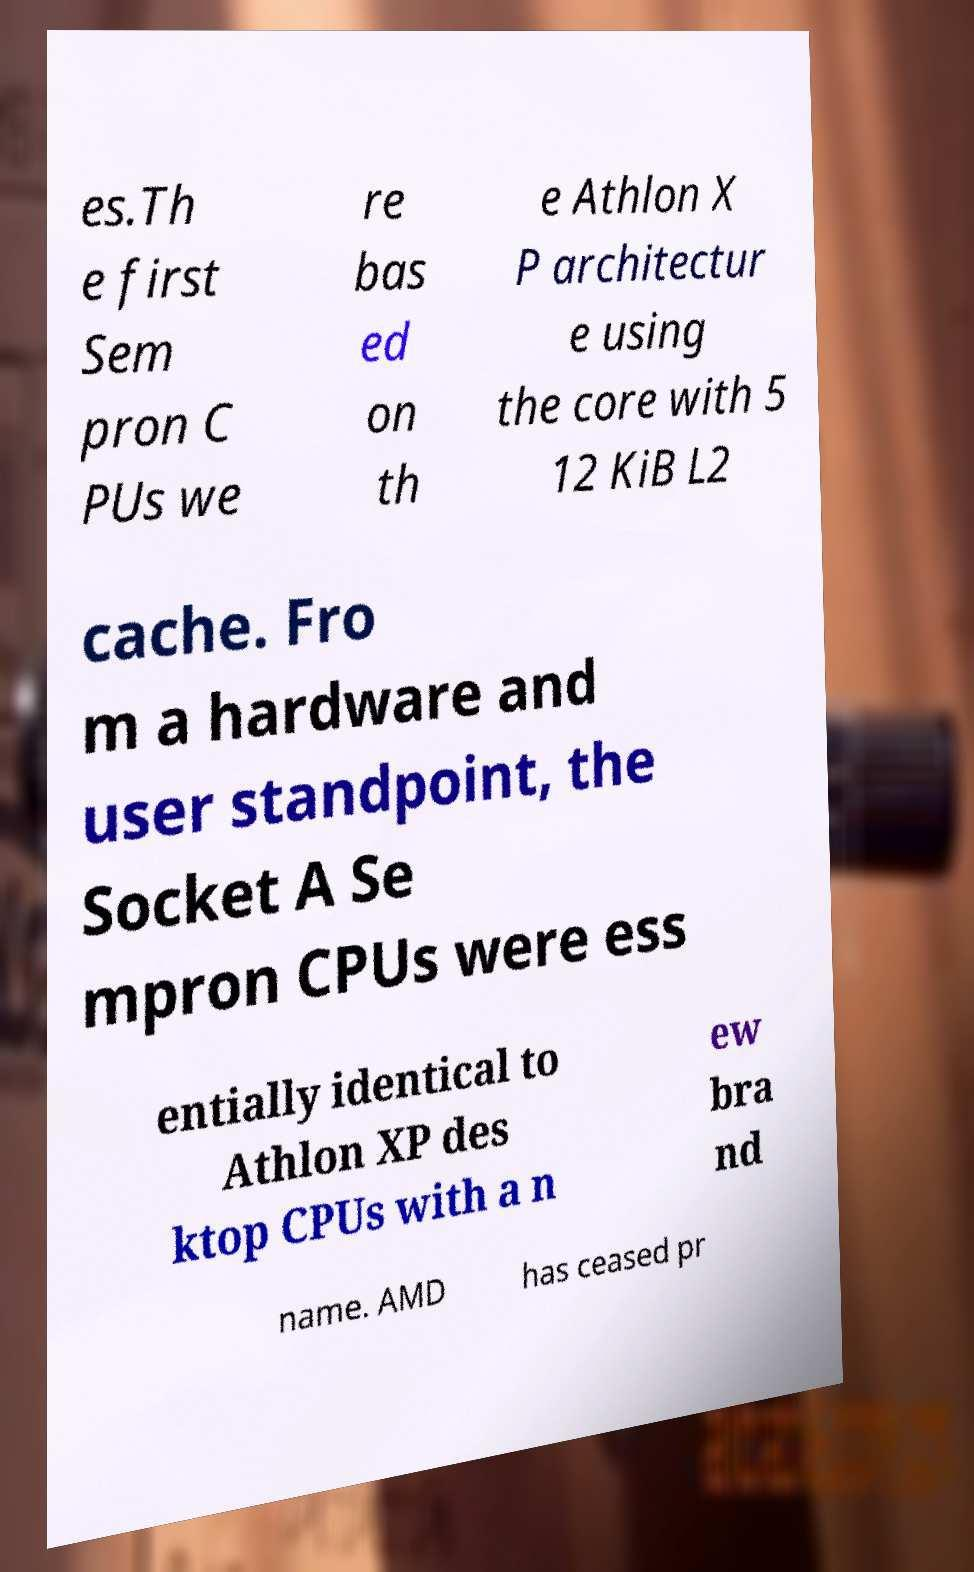Please read and relay the text visible in this image. What does it say? es.Th e first Sem pron C PUs we re bas ed on th e Athlon X P architectur e using the core with 5 12 KiB L2 cache. Fro m a hardware and user standpoint, the Socket A Se mpron CPUs were ess entially identical to Athlon XP des ktop CPUs with a n ew bra nd name. AMD has ceased pr 